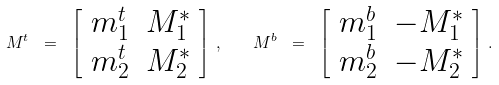Convert formula to latex. <formula><loc_0><loc_0><loc_500><loc_500>M ^ { t } \ = \ \left [ \begin{array} { c c } m ^ { t } _ { 1 } & M ^ { * } _ { 1 } \\ m ^ { t } _ { 2 } & M ^ { * } _ { 2 } \end{array} \right ] \, , \quad M ^ { b } \ = \ \left [ \begin{array} { c c } m ^ { b } _ { 1 } & - M ^ { * } _ { 1 } \\ m ^ { b } _ { 2 } & - M ^ { * } _ { 2 } \end{array} \right ] \, .</formula> 